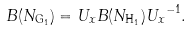Convert formula to latex. <formula><loc_0><loc_0><loc_500><loc_500>B ( { N _ { { \tt G } _ { 1 } } } ) = { U _ { x } } B ( { N _ { { \tt H } _ { 1 } } } ) { U _ { x } } ^ { - 1 } .</formula> 